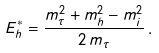<formula> <loc_0><loc_0><loc_500><loc_500>E _ { h } ^ { * } = \frac { m _ { \tau } ^ { 2 } + m _ { h } ^ { 2 } - m _ { i } ^ { 2 } } { 2 \, m _ { \tau } } \, .</formula> 